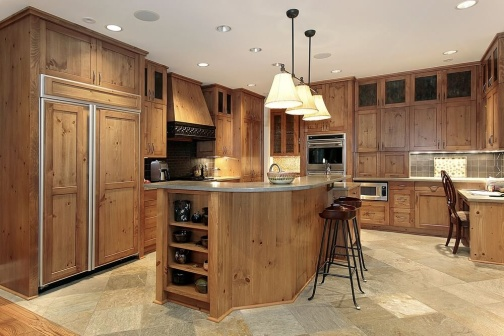What are some key functional features seen in this kitchen? This kitchen is equipped with several functional features including a built-in stainless steel refrigerator and a matching microwave nestled within the wooden cabinetry. The center island houses a sink and a built-in wine rack, optimized for accessibility and ease of use. The tile flooring is practical for easy cleaning and durability. Additionally, there’s plenty of cabinetry for storage, making the space practical as well as attractive. 